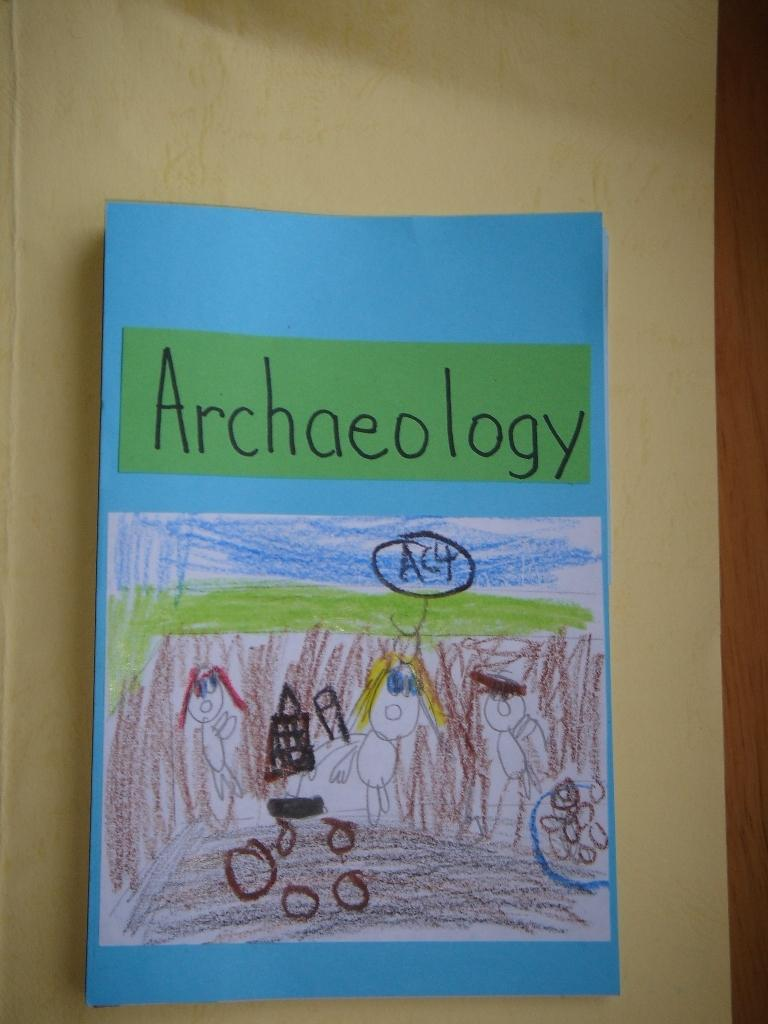<image>
Write a terse but informative summary of the picture. A child has drawn a picture of an Archaeology scene 